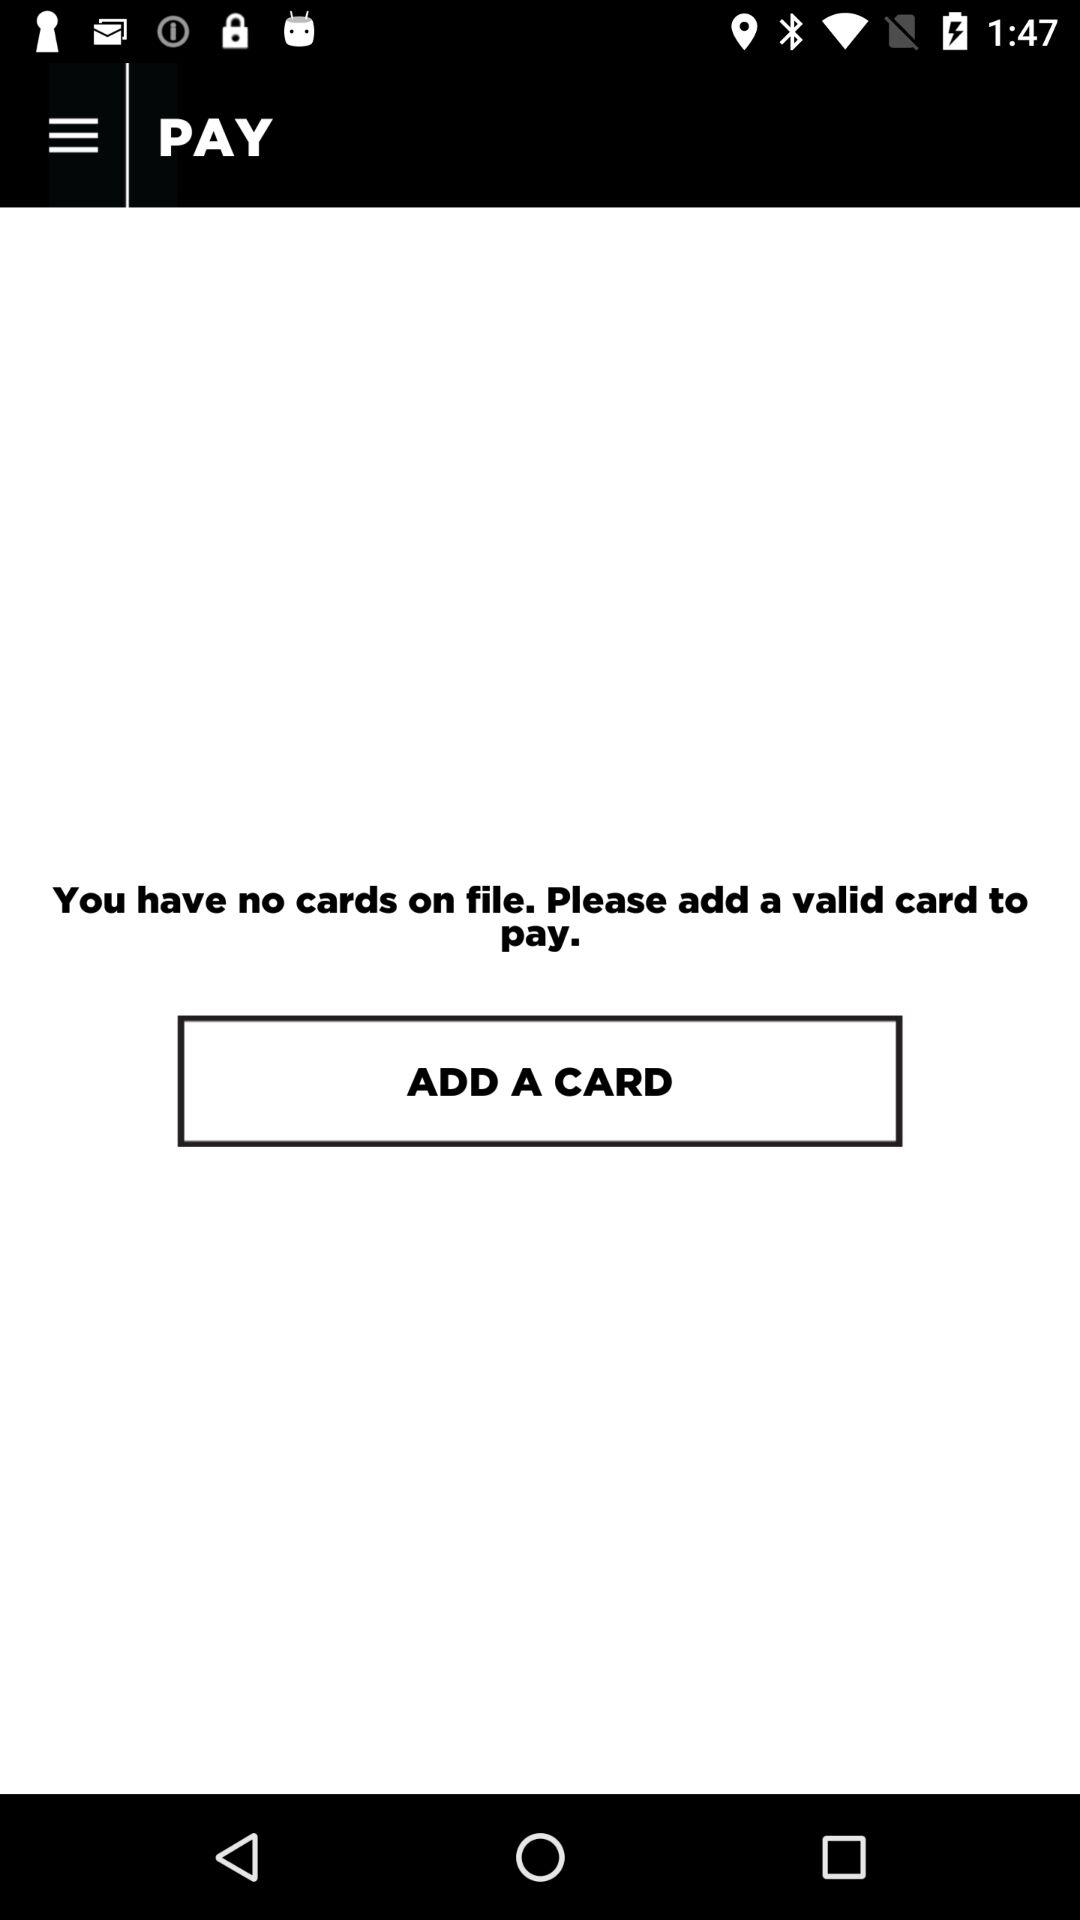Are there any cards on file? There are no cards on file. 